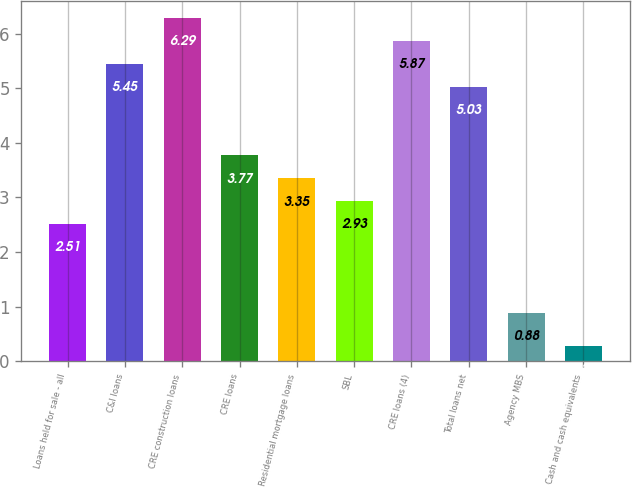Convert chart to OTSL. <chart><loc_0><loc_0><loc_500><loc_500><bar_chart><fcel>Loans held for sale - all<fcel>C&I loans<fcel>CRE construction loans<fcel>CRE loans<fcel>Residential mortgage loans<fcel>SBL<fcel>CRE loans (4)<fcel>Total loans net<fcel>Agency MBS<fcel>Cash and cash equivalents<nl><fcel>2.51<fcel>5.45<fcel>6.29<fcel>3.77<fcel>3.35<fcel>2.93<fcel>5.87<fcel>5.03<fcel>0.88<fcel>0.28<nl></chart> 